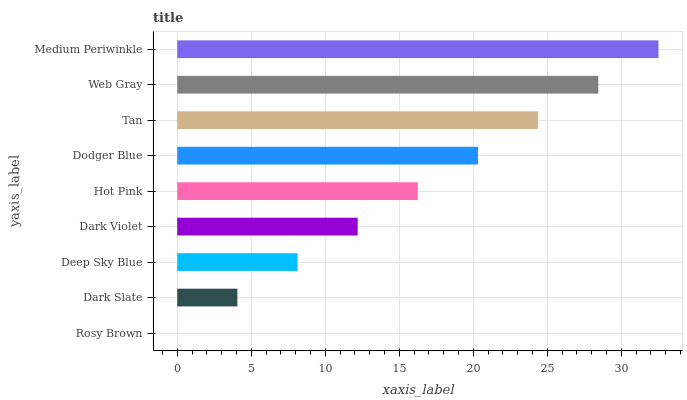Is Rosy Brown the minimum?
Answer yes or no. Yes. Is Medium Periwinkle the maximum?
Answer yes or no. Yes. Is Dark Slate the minimum?
Answer yes or no. No. Is Dark Slate the maximum?
Answer yes or no. No. Is Dark Slate greater than Rosy Brown?
Answer yes or no. Yes. Is Rosy Brown less than Dark Slate?
Answer yes or no. Yes. Is Rosy Brown greater than Dark Slate?
Answer yes or no. No. Is Dark Slate less than Rosy Brown?
Answer yes or no. No. Is Hot Pink the high median?
Answer yes or no. Yes. Is Hot Pink the low median?
Answer yes or no. Yes. Is Dark Slate the high median?
Answer yes or no. No. Is Deep Sky Blue the low median?
Answer yes or no. No. 